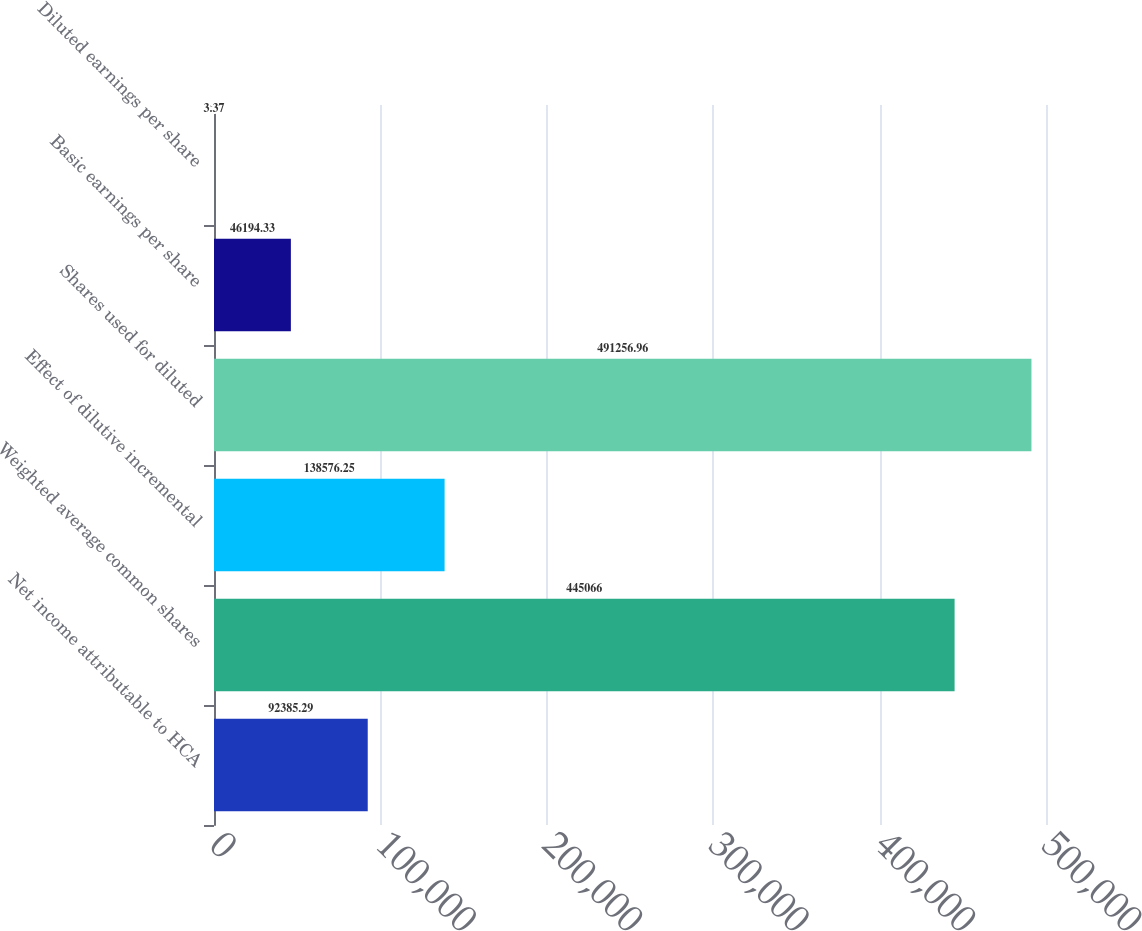Convert chart. <chart><loc_0><loc_0><loc_500><loc_500><bar_chart><fcel>Net income attributable to HCA<fcel>Weighted average common shares<fcel>Effect of dilutive incremental<fcel>Shares used for diluted<fcel>Basic earnings per share<fcel>Diluted earnings per share<nl><fcel>92385.3<fcel>445066<fcel>138576<fcel>491257<fcel>46194.3<fcel>3.37<nl></chart> 